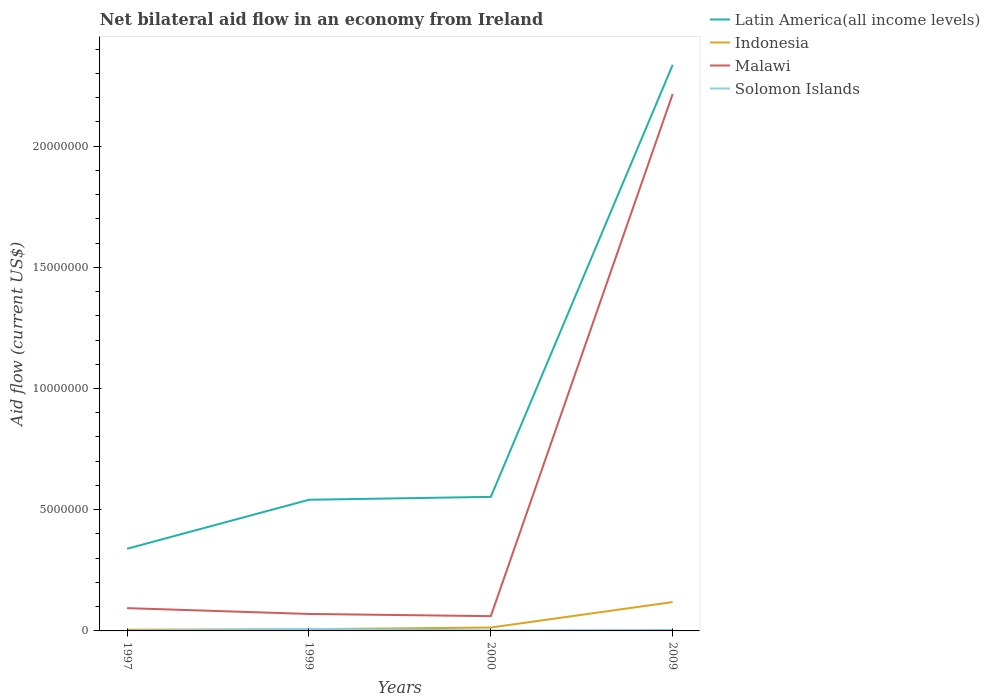Across all years, what is the maximum net bilateral aid flow in Latin America(all income levels)?
Give a very brief answer. 3.39e+06. In which year was the net bilateral aid flow in Indonesia maximum?
Make the answer very short. 1997. What is the total net bilateral aid flow in Indonesia in the graph?
Offer a very short reply. -1.05e+06. What is the difference between the highest and the second highest net bilateral aid flow in Malawi?
Keep it short and to the point. 2.15e+07. Is the net bilateral aid flow in Latin America(all income levels) strictly greater than the net bilateral aid flow in Indonesia over the years?
Offer a terse response. No. What is the difference between two consecutive major ticks on the Y-axis?
Your answer should be very brief. 5.00e+06. Does the graph contain any zero values?
Keep it short and to the point. No. Does the graph contain grids?
Keep it short and to the point. No. How many legend labels are there?
Make the answer very short. 4. What is the title of the graph?
Make the answer very short. Net bilateral aid flow in an economy from Ireland. Does "Trinidad and Tobago" appear as one of the legend labels in the graph?
Offer a very short reply. No. What is the label or title of the Y-axis?
Your answer should be compact. Aid flow (current US$). What is the Aid flow (current US$) in Latin America(all income levels) in 1997?
Ensure brevity in your answer.  3.39e+06. What is the Aid flow (current US$) of Indonesia in 1997?
Your response must be concise. 5.00e+04. What is the Aid flow (current US$) of Malawi in 1997?
Provide a short and direct response. 9.40e+05. What is the Aid flow (current US$) of Latin America(all income levels) in 1999?
Give a very brief answer. 5.41e+06. What is the Aid flow (current US$) in Malawi in 1999?
Make the answer very short. 7.00e+05. What is the Aid flow (current US$) of Latin America(all income levels) in 2000?
Your answer should be very brief. 5.53e+06. What is the Aid flow (current US$) in Latin America(all income levels) in 2009?
Make the answer very short. 2.34e+07. What is the Aid flow (current US$) of Indonesia in 2009?
Ensure brevity in your answer.  1.19e+06. What is the Aid flow (current US$) in Malawi in 2009?
Offer a very short reply. 2.22e+07. Across all years, what is the maximum Aid flow (current US$) in Latin America(all income levels)?
Make the answer very short. 2.34e+07. Across all years, what is the maximum Aid flow (current US$) in Indonesia?
Make the answer very short. 1.19e+06. Across all years, what is the maximum Aid flow (current US$) of Malawi?
Your answer should be compact. 2.22e+07. Across all years, what is the maximum Aid flow (current US$) of Solomon Islands?
Provide a succinct answer. 8.00e+04. Across all years, what is the minimum Aid flow (current US$) of Latin America(all income levels)?
Provide a short and direct response. 3.39e+06. Across all years, what is the minimum Aid flow (current US$) of Malawi?
Your answer should be very brief. 6.10e+05. Across all years, what is the minimum Aid flow (current US$) in Solomon Islands?
Offer a terse response. 10000. What is the total Aid flow (current US$) in Latin America(all income levels) in the graph?
Offer a very short reply. 3.77e+07. What is the total Aid flow (current US$) of Indonesia in the graph?
Ensure brevity in your answer.  1.45e+06. What is the total Aid flow (current US$) in Malawi in the graph?
Give a very brief answer. 2.44e+07. What is the difference between the Aid flow (current US$) of Latin America(all income levels) in 1997 and that in 1999?
Provide a short and direct response. -2.02e+06. What is the difference between the Aid flow (current US$) in Indonesia in 1997 and that in 1999?
Your answer should be very brief. -2.00e+04. What is the difference between the Aid flow (current US$) of Malawi in 1997 and that in 1999?
Make the answer very short. 2.40e+05. What is the difference between the Aid flow (current US$) of Latin America(all income levels) in 1997 and that in 2000?
Offer a terse response. -2.14e+06. What is the difference between the Aid flow (current US$) of Solomon Islands in 1997 and that in 2000?
Provide a short and direct response. -10000. What is the difference between the Aid flow (current US$) of Latin America(all income levels) in 1997 and that in 2009?
Your response must be concise. -2.00e+07. What is the difference between the Aid flow (current US$) in Indonesia in 1997 and that in 2009?
Keep it short and to the point. -1.14e+06. What is the difference between the Aid flow (current US$) in Malawi in 1997 and that in 2009?
Your response must be concise. -2.12e+07. What is the difference between the Aid flow (current US$) of Indonesia in 1999 and that in 2000?
Your response must be concise. -7.00e+04. What is the difference between the Aid flow (current US$) of Malawi in 1999 and that in 2000?
Your response must be concise. 9.00e+04. What is the difference between the Aid flow (current US$) in Latin America(all income levels) in 1999 and that in 2009?
Make the answer very short. -1.79e+07. What is the difference between the Aid flow (current US$) of Indonesia in 1999 and that in 2009?
Your response must be concise. -1.12e+06. What is the difference between the Aid flow (current US$) in Malawi in 1999 and that in 2009?
Keep it short and to the point. -2.14e+07. What is the difference between the Aid flow (current US$) in Latin America(all income levels) in 2000 and that in 2009?
Your answer should be compact. -1.78e+07. What is the difference between the Aid flow (current US$) of Indonesia in 2000 and that in 2009?
Your response must be concise. -1.05e+06. What is the difference between the Aid flow (current US$) of Malawi in 2000 and that in 2009?
Your response must be concise. -2.15e+07. What is the difference between the Aid flow (current US$) in Latin America(all income levels) in 1997 and the Aid flow (current US$) in Indonesia in 1999?
Your answer should be compact. 3.32e+06. What is the difference between the Aid flow (current US$) in Latin America(all income levels) in 1997 and the Aid flow (current US$) in Malawi in 1999?
Offer a very short reply. 2.69e+06. What is the difference between the Aid flow (current US$) in Latin America(all income levels) in 1997 and the Aid flow (current US$) in Solomon Islands in 1999?
Ensure brevity in your answer.  3.31e+06. What is the difference between the Aid flow (current US$) in Indonesia in 1997 and the Aid flow (current US$) in Malawi in 1999?
Provide a short and direct response. -6.50e+05. What is the difference between the Aid flow (current US$) of Indonesia in 1997 and the Aid flow (current US$) of Solomon Islands in 1999?
Your answer should be very brief. -3.00e+04. What is the difference between the Aid flow (current US$) of Malawi in 1997 and the Aid flow (current US$) of Solomon Islands in 1999?
Give a very brief answer. 8.60e+05. What is the difference between the Aid flow (current US$) in Latin America(all income levels) in 1997 and the Aid flow (current US$) in Indonesia in 2000?
Give a very brief answer. 3.25e+06. What is the difference between the Aid flow (current US$) of Latin America(all income levels) in 1997 and the Aid flow (current US$) of Malawi in 2000?
Offer a very short reply. 2.78e+06. What is the difference between the Aid flow (current US$) of Latin America(all income levels) in 1997 and the Aid flow (current US$) of Solomon Islands in 2000?
Keep it short and to the point. 3.37e+06. What is the difference between the Aid flow (current US$) in Indonesia in 1997 and the Aid flow (current US$) in Malawi in 2000?
Your answer should be compact. -5.60e+05. What is the difference between the Aid flow (current US$) of Malawi in 1997 and the Aid flow (current US$) of Solomon Islands in 2000?
Your answer should be compact. 9.20e+05. What is the difference between the Aid flow (current US$) in Latin America(all income levels) in 1997 and the Aid flow (current US$) in Indonesia in 2009?
Provide a succinct answer. 2.20e+06. What is the difference between the Aid flow (current US$) of Latin America(all income levels) in 1997 and the Aid flow (current US$) of Malawi in 2009?
Offer a terse response. -1.88e+07. What is the difference between the Aid flow (current US$) in Latin America(all income levels) in 1997 and the Aid flow (current US$) in Solomon Islands in 2009?
Make the answer very short. 3.35e+06. What is the difference between the Aid flow (current US$) in Indonesia in 1997 and the Aid flow (current US$) in Malawi in 2009?
Offer a very short reply. -2.21e+07. What is the difference between the Aid flow (current US$) in Malawi in 1997 and the Aid flow (current US$) in Solomon Islands in 2009?
Offer a terse response. 9.00e+05. What is the difference between the Aid flow (current US$) in Latin America(all income levels) in 1999 and the Aid flow (current US$) in Indonesia in 2000?
Your answer should be compact. 5.27e+06. What is the difference between the Aid flow (current US$) of Latin America(all income levels) in 1999 and the Aid flow (current US$) of Malawi in 2000?
Offer a very short reply. 4.80e+06. What is the difference between the Aid flow (current US$) in Latin America(all income levels) in 1999 and the Aid flow (current US$) in Solomon Islands in 2000?
Your response must be concise. 5.39e+06. What is the difference between the Aid flow (current US$) of Indonesia in 1999 and the Aid flow (current US$) of Malawi in 2000?
Offer a very short reply. -5.40e+05. What is the difference between the Aid flow (current US$) in Indonesia in 1999 and the Aid flow (current US$) in Solomon Islands in 2000?
Your response must be concise. 5.00e+04. What is the difference between the Aid flow (current US$) in Malawi in 1999 and the Aid flow (current US$) in Solomon Islands in 2000?
Provide a short and direct response. 6.80e+05. What is the difference between the Aid flow (current US$) of Latin America(all income levels) in 1999 and the Aid flow (current US$) of Indonesia in 2009?
Keep it short and to the point. 4.22e+06. What is the difference between the Aid flow (current US$) of Latin America(all income levels) in 1999 and the Aid flow (current US$) of Malawi in 2009?
Give a very brief answer. -1.67e+07. What is the difference between the Aid flow (current US$) of Latin America(all income levels) in 1999 and the Aid flow (current US$) of Solomon Islands in 2009?
Provide a succinct answer. 5.37e+06. What is the difference between the Aid flow (current US$) of Indonesia in 1999 and the Aid flow (current US$) of Malawi in 2009?
Offer a terse response. -2.21e+07. What is the difference between the Aid flow (current US$) of Latin America(all income levels) in 2000 and the Aid flow (current US$) of Indonesia in 2009?
Make the answer very short. 4.34e+06. What is the difference between the Aid flow (current US$) in Latin America(all income levels) in 2000 and the Aid flow (current US$) in Malawi in 2009?
Offer a very short reply. -1.66e+07. What is the difference between the Aid flow (current US$) of Latin America(all income levels) in 2000 and the Aid flow (current US$) of Solomon Islands in 2009?
Your answer should be compact. 5.49e+06. What is the difference between the Aid flow (current US$) in Indonesia in 2000 and the Aid flow (current US$) in Malawi in 2009?
Provide a short and direct response. -2.20e+07. What is the difference between the Aid flow (current US$) of Indonesia in 2000 and the Aid flow (current US$) of Solomon Islands in 2009?
Provide a succinct answer. 1.00e+05. What is the difference between the Aid flow (current US$) of Malawi in 2000 and the Aid flow (current US$) of Solomon Islands in 2009?
Offer a very short reply. 5.70e+05. What is the average Aid flow (current US$) in Latin America(all income levels) per year?
Keep it short and to the point. 9.42e+06. What is the average Aid flow (current US$) of Indonesia per year?
Give a very brief answer. 3.62e+05. What is the average Aid flow (current US$) of Malawi per year?
Your answer should be very brief. 6.10e+06. What is the average Aid flow (current US$) in Solomon Islands per year?
Offer a terse response. 3.75e+04. In the year 1997, what is the difference between the Aid flow (current US$) in Latin America(all income levels) and Aid flow (current US$) in Indonesia?
Provide a short and direct response. 3.34e+06. In the year 1997, what is the difference between the Aid flow (current US$) of Latin America(all income levels) and Aid flow (current US$) of Malawi?
Give a very brief answer. 2.45e+06. In the year 1997, what is the difference between the Aid flow (current US$) in Latin America(all income levels) and Aid flow (current US$) in Solomon Islands?
Provide a succinct answer. 3.38e+06. In the year 1997, what is the difference between the Aid flow (current US$) in Indonesia and Aid flow (current US$) in Malawi?
Your response must be concise. -8.90e+05. In the year 1997, what is the difference between the Aid flow (current US$) in Indonesia and Aid flow (current US$) in Solomon Islands?
Your response must be concise. 4.00e+04. In the year 1997, what is the difference between the Aid flow (current US$) in Malawi and Aid flow (current US$) in Solomon Islands?
Your answer should be very brief. 9.30e+05. In the year 1999, what is the difference between the Aid flow (current US$) in Latin America(all income levels) and Aid flow (current US$) in Indonesia?
Provide a short and direct response. 5.34e+06. In the year 1999, what is the difference between the Aid flow (current US$) of Latin America(all income levels) and Aid flow (current US$) of Malawi?
Your response must be concise. 4.71e+06. In the year 1999, what is the difference between the Aid flow (current US$) of Latin America(all income levels) and Aid flow (current US$) of Solomon Islands?
Provide a succinct answer. 5.33e+06. In the year 1999, what is the difference between the Aid flow (current US$) of Indonesia and Aid flow (current US$) of Malawi?
Provide a succinct answer. -6.30e+05. In the year 1999, what is the difference between the Aid flow (current US$) in Indonesia and Aid flow (current US$) in Solomon Islands?
Keep it short and to the point. -10000. In the year 1999, what is the difference between the Aid flow (current US$) of Malawi and Aid flow (current US$) of Solomon Islands?
Keep it short and to the point. 6.20e+05. In the year 2000, what is the difference between the Aid flow (current US$) in Latin America(all income levels) and Aid flow (current US$) in Indonesia?
Give a very brief answer. 5.39e+06. In the year 2000, what is the difference between the Aid flow (current US$) of Latin America(all income levels) and Aid flow (current US$) of Malawi?
Provide a short and direct response. 4.92e+06. In the year 2000, what is the difference between the Aid flow (current US$) of Latin America(all income levels) and Aid flow (current US$) of Solomon Islands?
Make the answer very short. 5.51e+06. In the year 2000, what is the difference between the Aid flow (current US$) of Indonesia and Aid flow (current US$) of Malawi?
Keep it short and to the point. -4.70e+05. In the year 2000, what is the difference between the Aid flow (current US$) of Indonesia and Aid flow (current US$) of Solomon Islands?
Your answer should be compact. 1.20e+05. In the year 2000, what is the difference between the Aid flow (current US$) in Malawi and Aid flow (current US$) in Solomon Islands?
Your answer should be compact. 5.90e+05. In the year 2009, what is the difference between the Aid flow (current US$) in Latin America(all income levels) and Aid flow (current US$) in Indonesia?
Give a very brief answer. 2.22e+07. In the year 2009, what is the difference between the Aid flow (current US$) in Latin America(all income levels) and Aid flow (current US$) in Malawi?
Provide a succinct answer. 1.20e+06. In the year 2009, what is the difference between the Aid flow (current US$) of Latin America(all income levels) and Aid flow (current US$) of Solomon Islands?
Your response must be concise. 2.33e+07. In the year 2009, what is the difference between the Aid flow (current US$) of Indonesia and Aid flow (current US$) of Malawi?
Your answer should be very brief. -2.10e+07. In the year 2009, what is the difference between the Aid flow (current US$) in Indonesia and Aid flow (current US$) in Solomon Islands?
Make the answer very short. 1.15e+06. In the year 2009, what is the difference between the Aid flow (current US$) in Malawi and Aid flow (current US$) in Solomon Islands?
Give a very brief answer. 2.21e+07. What is the ratio of the Aid flow (current US$) in Latin America(all income levels) in 1997 to that in 1999?
Ensure brevity in your answer.  0.63. What is the ratio of the Aid flow (current US$) in Indonesia in 1997 to that in 1999?
Give a very brief answer. 0.71. What is the ratio of the Aid flow (current US$) in Malawi in 1997 to that in 1999?
Make the answer very short. 1.34. What is the ratio of the Aid flow (current US$) in Latin America(all income levels) in 1997 to that in 2000?
Make the answer very short. 0.61. What is the ratio of the Aid flow (current US$) of Indonesia in 1997 to that in 2000?
Keep it short and to the point. 0.36. What is the ratio of the Aid flow (current US$) in Malawi in 1997 to that in 2000?
Keep it short and to the point. 1.54. What is the ratio of the Aid flow (current US$) in Latin America(all income levels) in 1997 to that in 2009?
Provide a short and direct response. 0.15. What is the ratio of the Aid flow (current US$) of Indonesia in 1997 to that in 2009?
Your answer should be compact. 0.04. What is the ratio of the Aid flow (current US$) in Malawi in 1997 to that in 2009?
Make the answer very short. 0.04. What is the ratio of the Aid flow (current US$) in Solomon Islands in 1997 to that in 2009?
Offer a terse response. 0.25. What is the ratio of the Aid flow (current US$) in Latin America(all income levels) in 1999 to that in 2000?
Make the answer very short. 0.98. What is the ratio of the Aid flow (current US$) in Malawi in 1999 to that in 2000?
Provide a short and direct response. 1.15. What is the ratio of the Aid flow (current US$) in Latin America(all income levels) in 1999 to that in 2009?
Keep it short and to the point. 0.23. What is the ratio of the Aid flow (current US$) of Indonesia in 1999 to that in 2009?
Your response must be concise. 0.06. What is the ratio of the Aid flow (current US$) of Malawi in 1999 to that in 2009?
Make the answer very short. 0.03. What is the ratio of the Aid flow (current US$) of Latin America(all income levels) in 2000 to that in 2009?
Offer a terse response. 0.24. What is the ratio of the Aid flow (current US$) of Indonesia in 2000 to that in 2009?
Offer a terse response. 0.12. What is the ratio of the Aid flow (current US$) of Malawi in 2000 to that in 2009?
Your answer should be compact. 0.03. What is the difference between the highest and the second highest Aid flow (current US$) of Latin America(all income levels)?
Your answer should be compact. 1.78e+07. What is the difference between the highest and the second highest Aid flow (current US$) in Indonesia?
Offer a very short reply. 1.05e+06. What is the difference between the highest and the second highest Aid flow (current US$) of Malawi?
Offer a very short reply. 2.12e+07. What is the difference between the highest and the second highest Aid flow (current US$) in Solomon Islands?
Offer a terse response. 4.00e+04. What is the difference between the highest and the lowest Aid flow (current US$) of Latin America(all income levels)?
Your answer should be very brief. 2.00e+07. What is the difference between the highest and the lowest Aid flow (current US$) in Indonesia?
Ensure brevity in your answer.  1.14e+06. What is the difference between the highest and the lowest Aid flow (current US$) of Malawi?
Keep it short and to the point. 2.15e+07. What is the difference between the highest and the lowest Aid flow (current US$) in Solomon Islands?
Offer a terse response. 7.00e+04. 